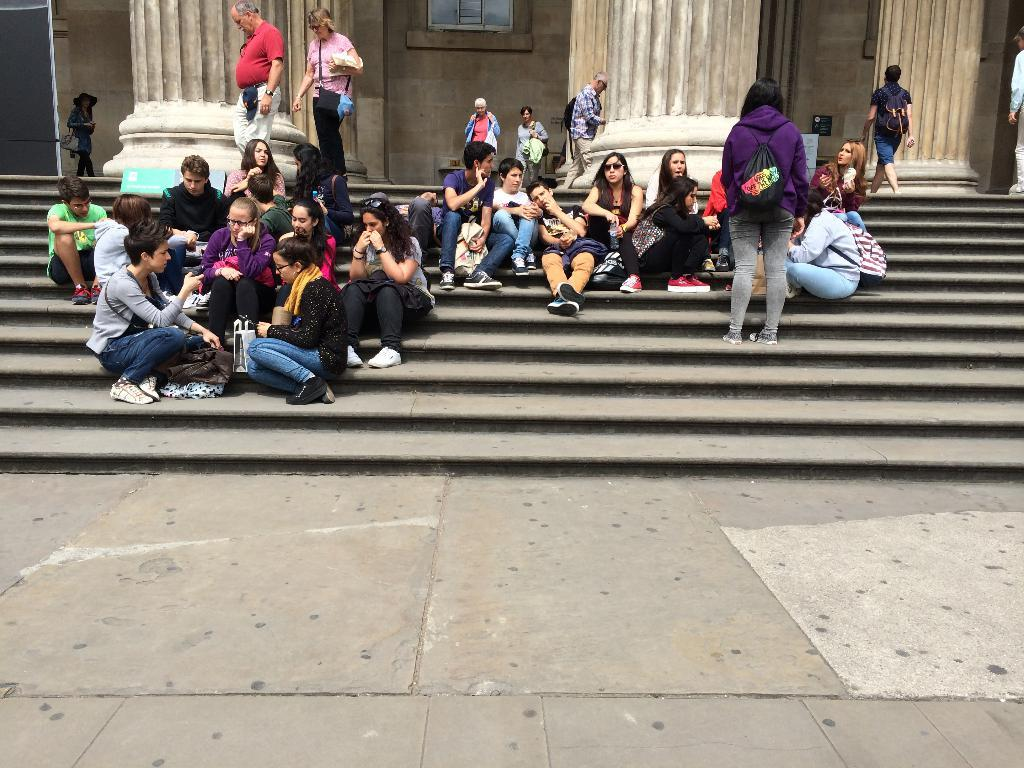What are the people in the image doing? The people in the image are sitting and standing on steps. What architectural features can be seen in the background of the image? There are pillars and a wall visible in the background of the image. What type of pump is being used by the people sitting on the steps in the image? There is no pump present in the image; the people are simply sitting and standing on steps. 